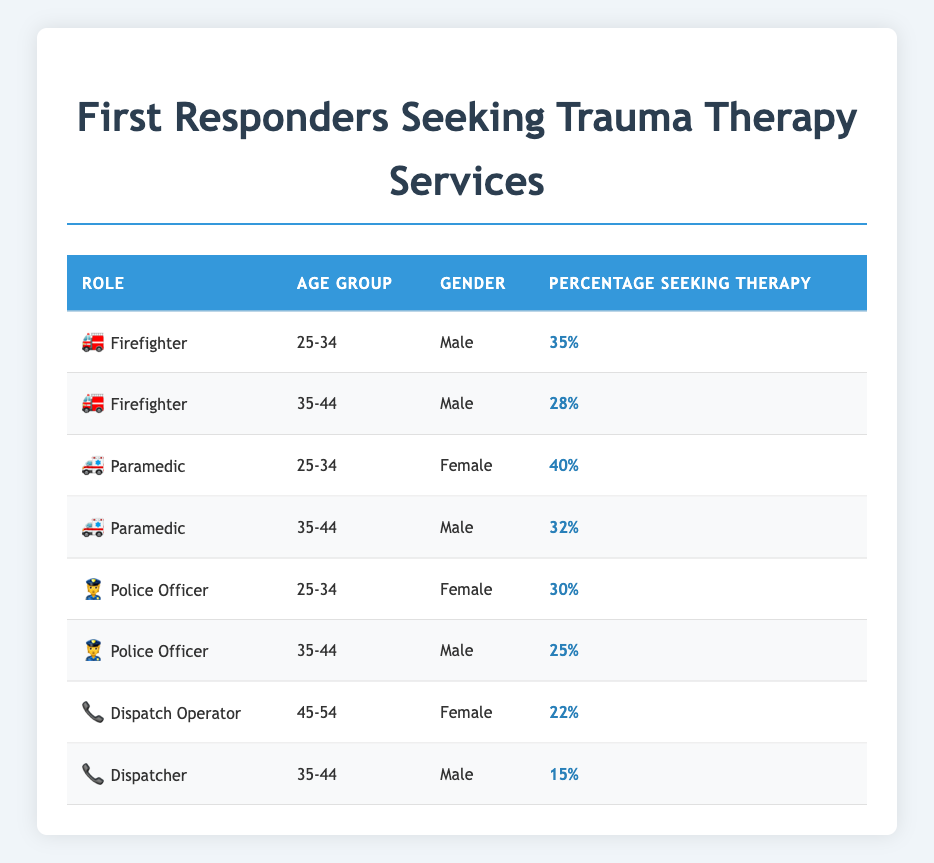What percentage of paramedics aged 25-34 are seeking therapy? According to the table, the entry for paramedics aged 25-34 shows that 40% are seeking therapy.
Answer: 40% Which demographic group has the highest percentage of individuals seeking therapy? By reviewing the table, the paramedic group aged 25-34 with 40% seeking therapy has the highest percentage compared to the other demographics listed.
Answer: Paramedics aged 25-34 Is it true that more male firefighters aged 35-44 seek therapy than male police officers in the same age group? From the table, male firefighters aged 35-44 have 28% seeking therapy, while male police officers in the same age group have only 25% seeking therapy. Thus, it is true that more male firefighters seek therapy.
Answer: Yes What is the difference in percentage seeking therapy between female paramedics aged 25-34 and male dispatchers aged 35-44? The percentage of female paramedics seeking therapy is 40%, and the percentage of male dispatchers is 15%. To find the difference, subtract 15 from 40, which is 25.
Answer: 25% What percentage of police officers aged 25-34 are seeking therapy compared to dispatch operators aged 45-54? Police officers aged 25-34 have 30% seeking therapy, while dispatch operators aged 45-54 have 22%. Subtracting these figures gives a difference of 8%, meaning police officers in this age group have a higher percentage seeking therapy.
Answer: 8% How many total entries are there for males in the table? The table includes five male entries: firefighters aged 25-34, firefighters aged 35-44, paramedics aged 35-44, police officers aged 35-44, and dispatchers aged 35-44. Therefore, the total number of entries for males is 5.
Answer: 5 What is the average percentage seeking therapy for firefighters? There are two firefighter entries: 35% for those aged 25-34 and 28% for those aged 35-44. Their total is 63%, and dividing by 2 (the number of entries) gives an average of 31.5%.
Answer: 31.5% Are more than 20% of female dispatch operators seeking therapy? From the table, the percentage of female dispatch operators seeking therapy is 22%, which is indeed more than 20%.
Answer: Yes 